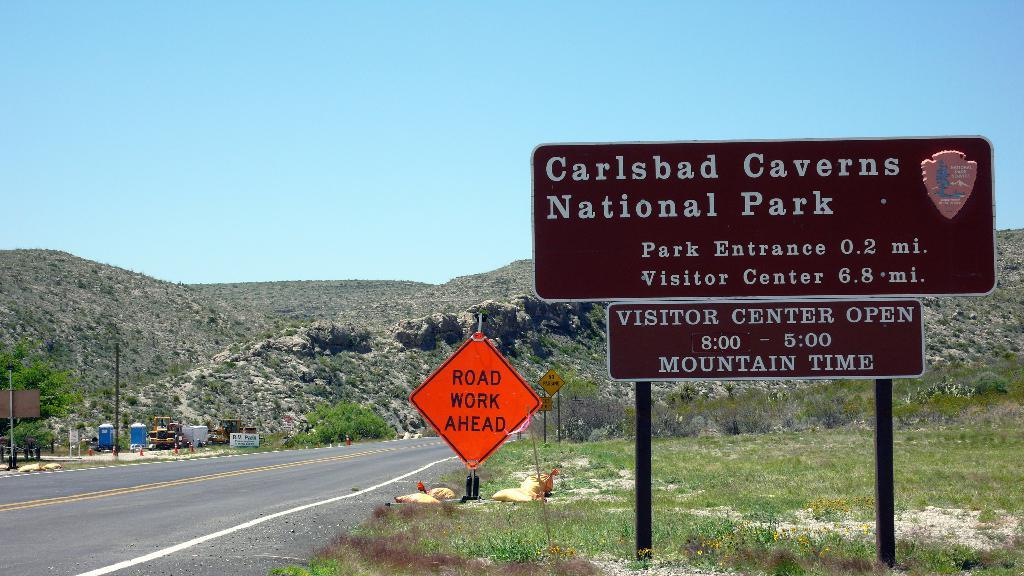<image>
Share a concise interpretation of the image provided. A sign for Carlsbad Caverns National Park says the entrance is 0.2 miles away. 